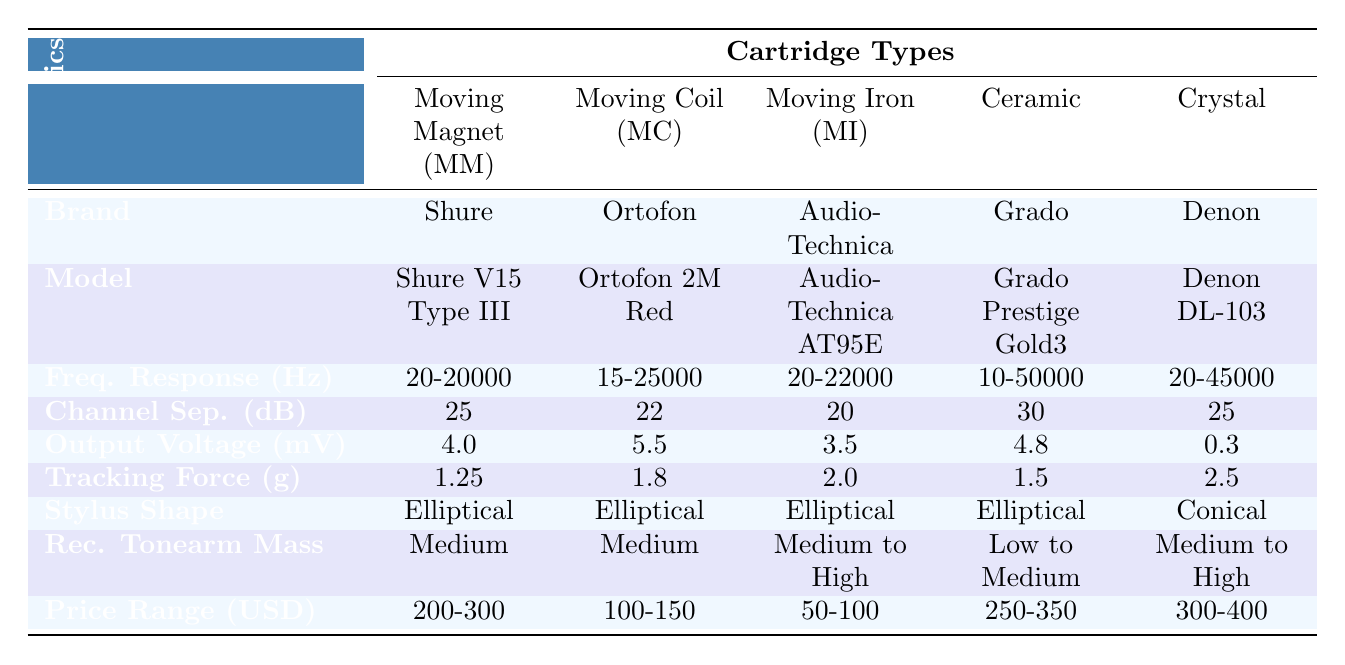What is the frequency response range of the Moving Coil (MC) cartridge type? According to the table, the frequency response for the Moving Coil (MC) type is noted as 15-25000 Hz.
Answer: 15-25000 Hz Which cartridge has the highest channel separation in dB? The table shows that the Ceramic cartridge has the highest channel separation value at 30 dB.
Answer: 30 dB What is the output voltage of the Denon DL-103? The table lists the output voltage for the Denon DL-103 as 0.3 mV.
Answer: 0.3 mV How many cartridges have an elliptical stylus shape? From the table, four cartridges (Shure V15 Type III, Ortofon 2M Red, Audio-Technica AT95E, and Grado Prestige Gold3) are listed with an elliptical stylus shape.
Answer: 4 What is the average tracking force for the Moving Iron (MI) and Moving Magnet (MM) cartridges? The tracking forces for the MI and MM cartridges are 2.0 grams and 1.25 grams, respectively. To find the average, we sum the values (2.0 + 1.25) = 3.25 grams and divide by 2, giving us an average of 1.625 grams.
Answer: 1.625 grams Which brand has the highest output voltage, and what is that value? When checking the output voltage values in the table, Ortofon has the highest output voltage at 5.5 mV.
Answer: Ortofon, 5.5 mV Is the recommended tonearm mass for the Grado Prestige Gold3 cartridge low to medium? According to the table, the recommended tonearm mass for the Grado Prestige Gold3 is noted as low to medium, indicating that this statement is true.
Answer: Yes What is the price range of the cartridge with the lowest output voltage? The Denon DL-103 cartridge has the lowest output voltage at 0.3 mV, and its price range is listed as 300-400 USD.
Answer: 300-400 USD Which cartridge types have a frequency response that goes up to 50 kHz or higher? The table shows that both the Ceramic (10-50000 Hz) and the Crystal (20-45000 Hz) cartridge types have frequency responses that reach up to 50 kHz or higher.
Answer: Ceramic Which has a higher channel separation, the Moving Magnet (MM) or Moving Iron (MI) cartridge? The table indicates that the Moving Magnet cartridge has a channel separation of 25 dB, while the Moving Iron has a channel separation of 20 dB. Therefore, 25 dB is higher than 20 dB.
Answer: Moving Magnet (MM) 